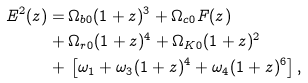<formula> <loc_0><loc_0><loc_500><loc_500>E ^ { 2 } ( z ) = & \, \Omega _ { b 0 } ( 1 + z ) ^ { 3 } + \Omega _ { c 0 } F ( z ) \\ + & \, \Omega _ { r 0 } ( 1 + z ) ^ { 4 } + \Omega _ { K 0 } ( 1 + z ) ^ { 2 } \\ + & \, \left [ \omega _ { 1 } + \omega _ { 3 } ( 1 + z ) ^ { 4 } + \omega _ { 4 } ( 1 + z ) ^ { 6 } \right ] ,</formula> 